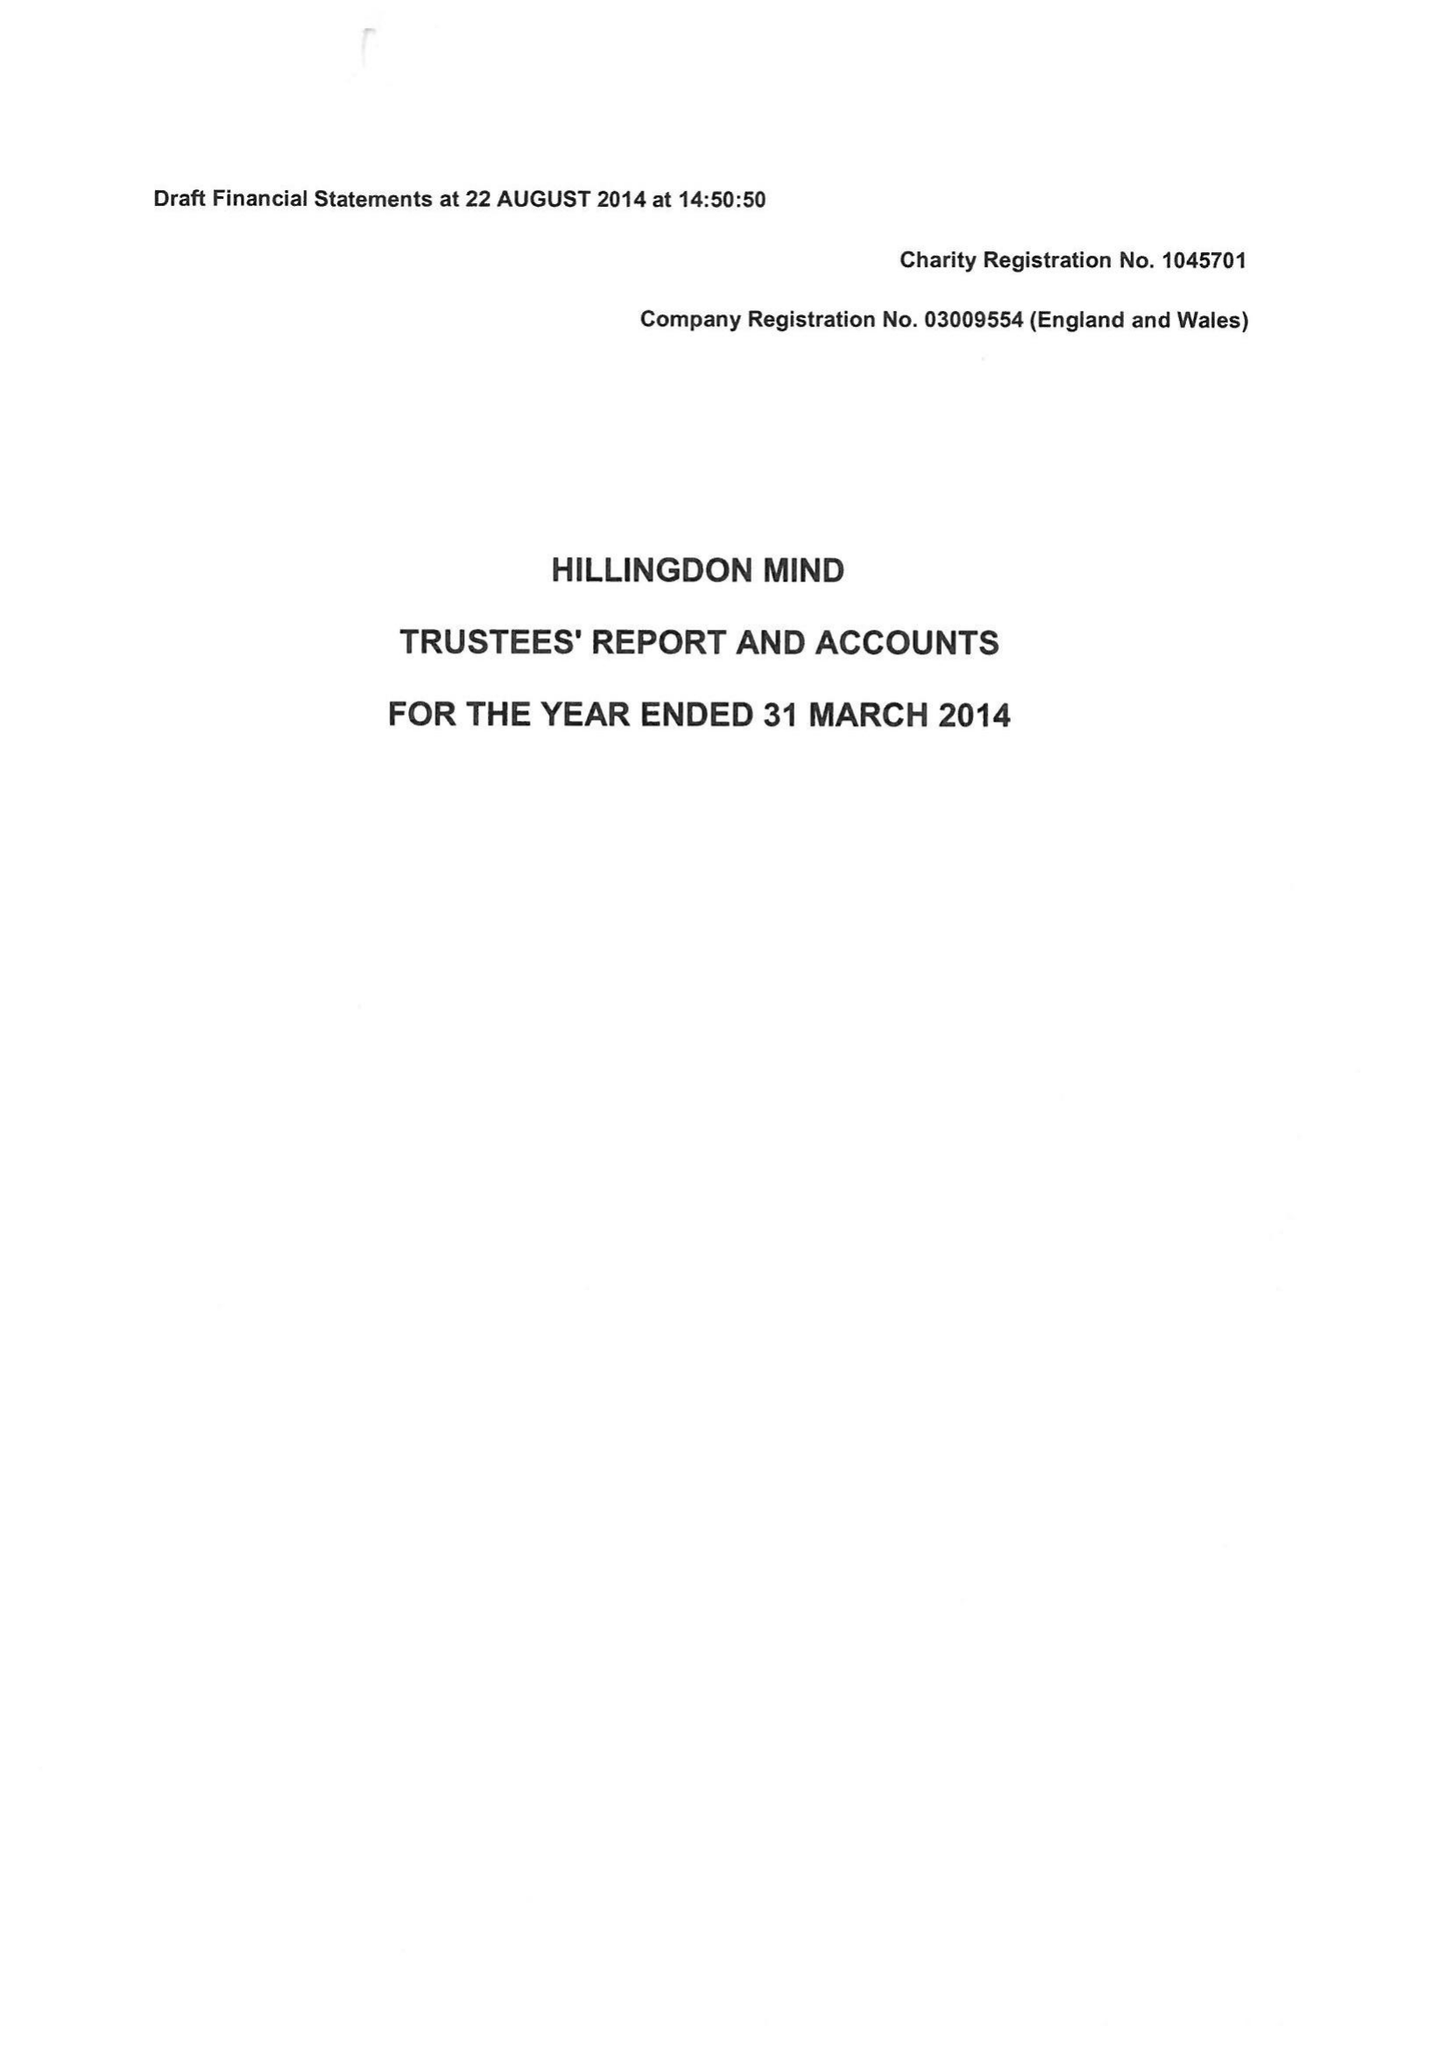What is the value for the address__post_town?
Answer the question using a single word or phrase. UXBRIDGE 